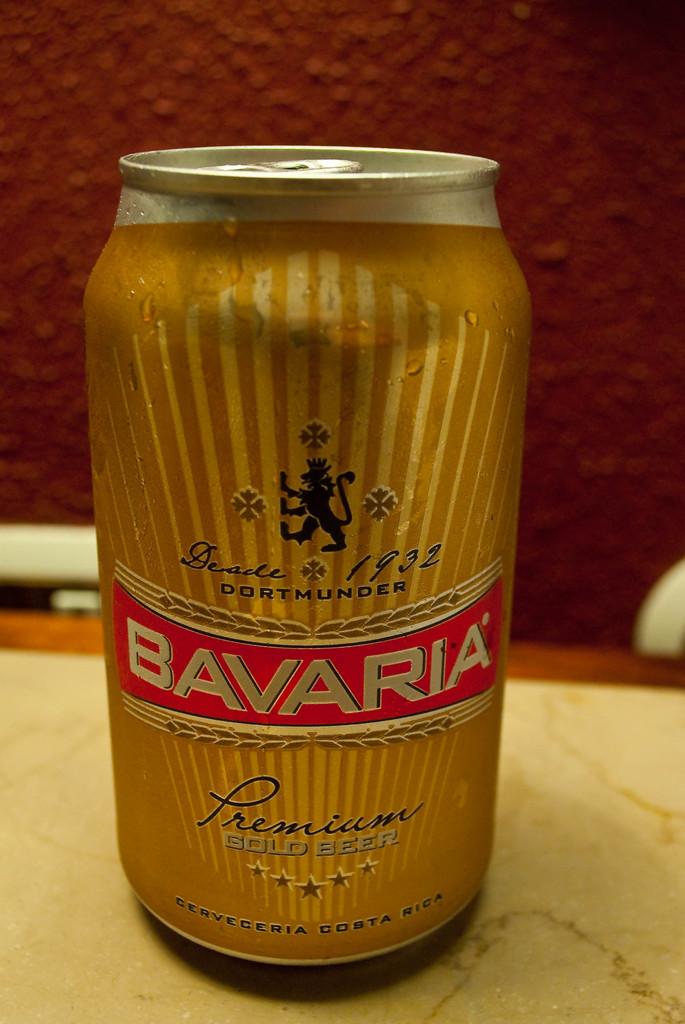Is this the name of a beverage?
Your answer should be very brief. Bavaria. Where is the beer from?
Provide a succinct answer. Costa rica. 